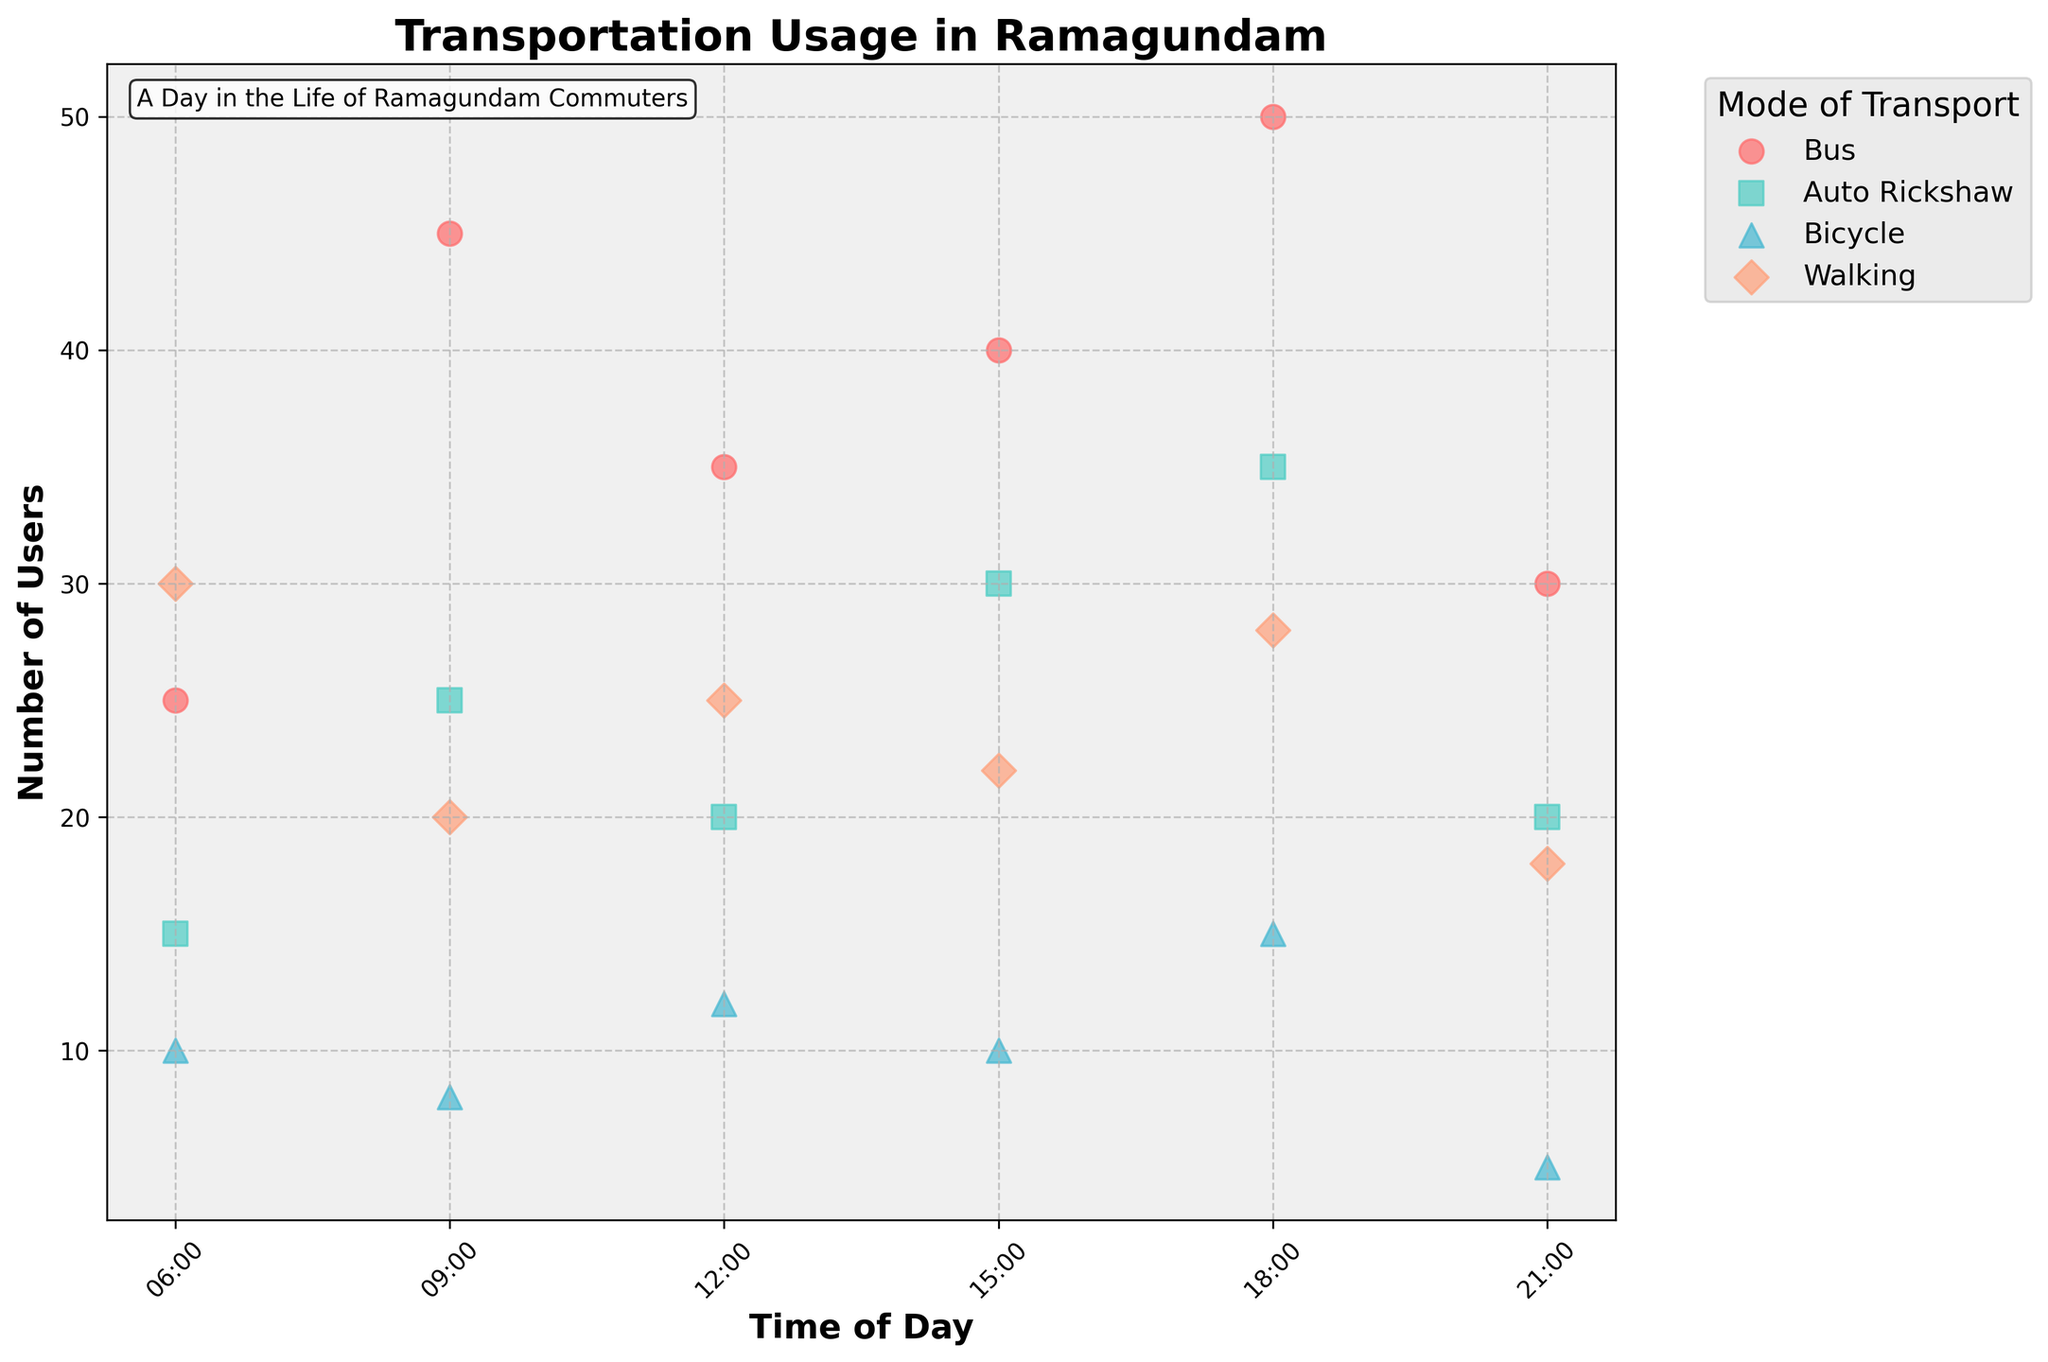What is the title of the plot? The title of the plot is typically located at the top and gives a summary of the visual information being presented. In this case, it is "Transportation Usage in Ramagundam."
Answer: Transportation Usage in Ramagundam How many users chose auto rickshaws at 18:00? To find the number of users for auto rickshaws at 18:00, one would look for the data point corresponding to 18:00 along the x-axis and check the y-value for the auto rickshaw category.
Answer: 35 Which mode of transport had the highest number of users at 09:00? To determine this, locate the 09:00 time point on the x-axis, then compare the y-values of all modes of transport for this specific time. The highest y-value indicates the mode with the most users.
Answer: Bus What is the total number of users for bicycles throughout the day? Sum the number of users for bicycles at all the different times of day provided. The sum is 10 + 8 + 12 + 10 + 15 + 5.
Answer: 60 At what time did walking have the maximum number of users? Compare the y-values for walking at each time point on the x-axis to find the maximum.
Answer: 06:00 How does the number of bus users at 21:00 compare to the number of walking users at the same time? Check the y-values for buses and walking at 21:00 on the x-axis and compare them.
Answer: Bus users are more What is the difference in the number of users between buses and auto rickshaws at 15:00? Find the number of users for buses and auto rickshaws at 15:00 and calculate the difference by subtracting the auto rickshaw users from the bus users.
Answer: 10 Which mode of transport has the most consistent number of users throughout the day? To determine consistency, assess the fluctuations in the number of users for each mode of transport across all times. The mode with the least fluctuation is the most consistent.
Answer: Bicycle What times are associated with the least number of bicycle users? Identify all the time points on the x-axis and check the y-values for bicycles to find the minimum values.
Answer: 09:00 and 21:00 How does the pattern of bus usage change throughout the day? Observe the scatter points for buses across all times to identify an overall trend or pattern in the number of users.
Answer: Increases, peaks at 18:00, then drops 